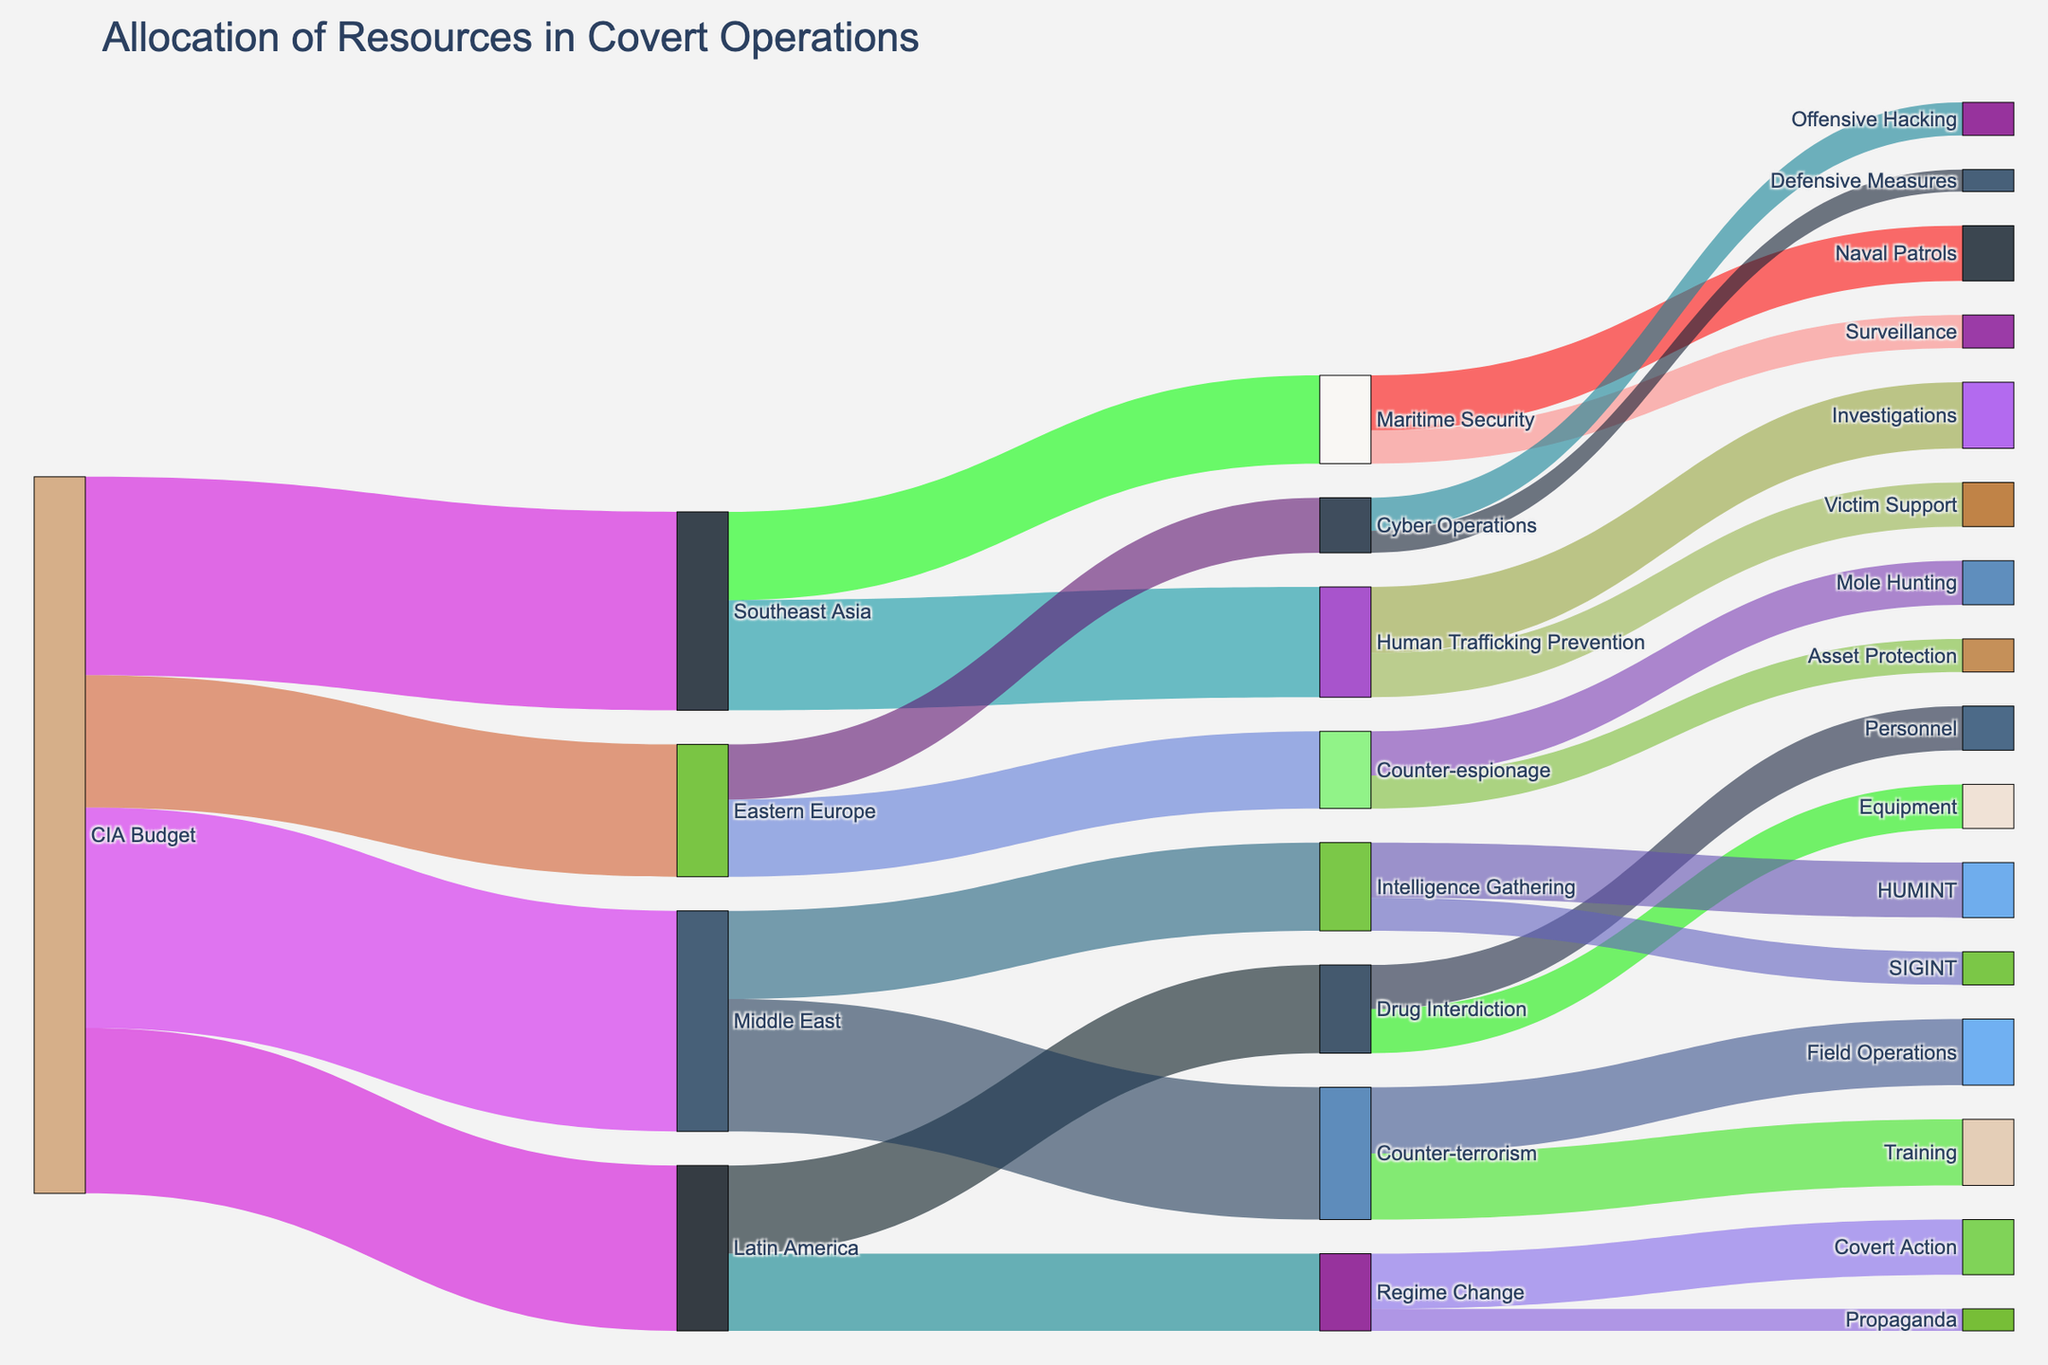what's the main focus in Latin America? Look at the flows originating from Latin America. The two targets for Latin America are Drug Interdiction (80) and Regime Change (70). The highest value flow is Drug Interdiction.
Answer: Drug Interdiction How many resources are allocated to Intelligence Gathering in the Middle East? Observe the thickness of the flows from Middle East to its targets. The value for Counter-terrorism is 120 and for Intelligence Gathering is 80.
Answer: 80 Compare the resource allocation between Southeast Asia's objectives. Which one receives more resources? Check the flow values coming out of Southeast Asia. The two objectives are Human Trafficking Prevention (100) and Maritime Security (80). Human Trafficking Prevention receives more resources.
Answer: Human Trafficking Prevention What's the sum of resources allocated to Counter-terrorism and Training in the Middle East? Identify the flow values for Counter-terrorism in the Middle East. Counter-terrorism gets 120 and splits to Training (60) and Field Operations (60). Their sum is 60 + 60 = 120.
Answer: 120 Which region has the least resource allocation? Compare the total flows from each region: Latin America (150), Middle East (200), Southeast Asia (180), and Eastern Europe (120). Eastern Europe has the least.
Answer: Eastern Europe How are resources allocated within Cyber Operations in Eastern Europe? Follow the flows starting from Cyber Operations in Eastern Europe. There are two targets: Offensive Hacking (30) and Defensive Measures (20).
Answer: Offensive Hacking gets 30 and Defensive Measures get 20 What's the smallest allocation for any sub-objective? Review all sub-objective allocation values. The smallest is Propaganda under Regime Change in Latin America, with 20.
Answer: 20 What's the combined allocation for Personnel and Equipment in Drug Interdiction? Add the resource values for Personnel (40) and Equipment (40) under Drug Interdiction: 40 + 40 = 80.
Answer: 80 Which activity in Eastern Europe has the highest resource allocation? Compare the flow values for activities within Eastern Europe. Counter-espionage (70) splits into Mole Hunting (40) and Asset Protection (30), Cyber Operations splits into Offensive Hacking (30) and Defensive Measures (20). Mole Hunting is the highest with 40.
Answer: Mole Hunting In terms of regions, which subject receives the highest resources? Aggregate and compare the values allocated from each region: Latin America (Drug Interdiction 80), Middle East (Counter-terrorism 120), Southeast Asia (Human Trafficking Prevention 100), Eastern Europe (Counter-espionage 70). Middle East's Counter-terrorism receives the highest.
Answer: Counter-terrorism in Middle East 